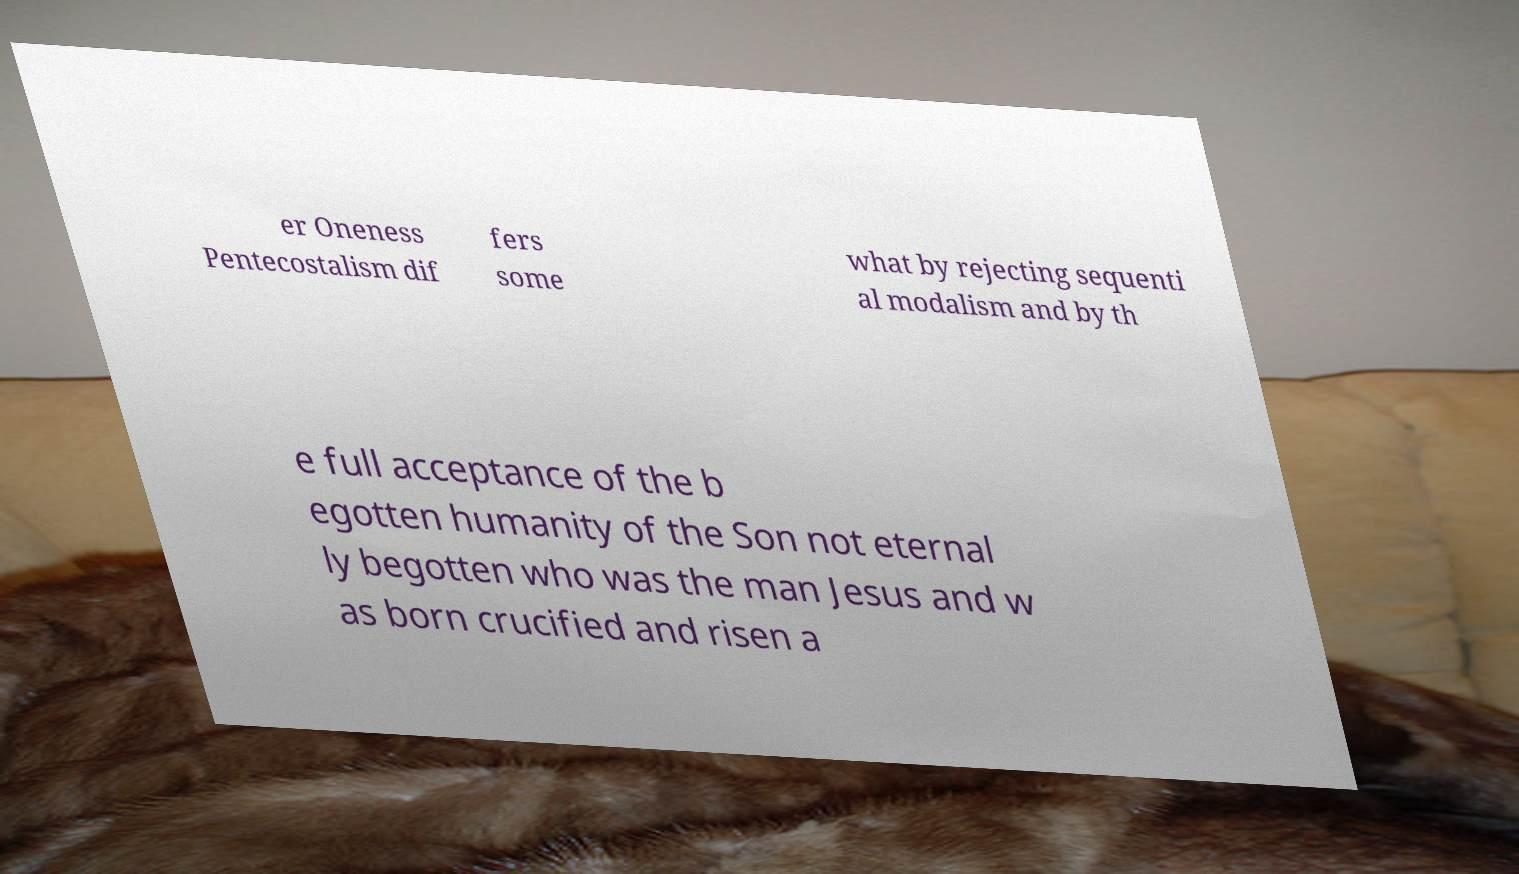Can you accurately transcribe the text from the provided image for me? er Oneness Pentecostalism dif fers some what by rejecting sequenti al modalism and by th e full acceptance of the b egotten humanity of the Son not eternal ly begotten who was the man Jesus and w as born crucified and risen a 